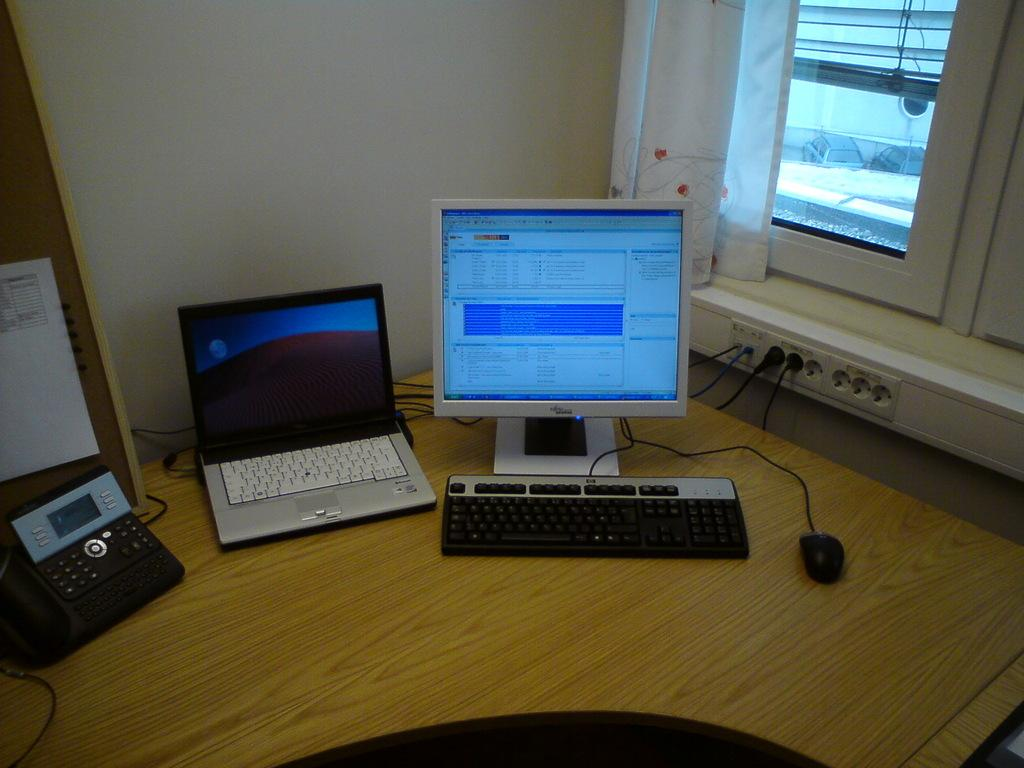What electronic device is visible in the image? There is a laptop in the image. What is the primary input device for the laptop? There is a keyboard in the image. What is the secondary input device for the laptop? There is a mouse in the image. What type of window is present in the image? There is a glass window in the image. What is the purpose of the curtain in the image? The curtain is likely used for privacy or light control. What communication device is present in the image? There is a telephone in the image. How does the digestion process of the laptop work in the image? The laptop does not have a digestion process, as it is an electronic device and not a living organism. Can you see any trees in the image? There is no mention of trees in the provided facts, so we cannot determine if they are present in the image. 